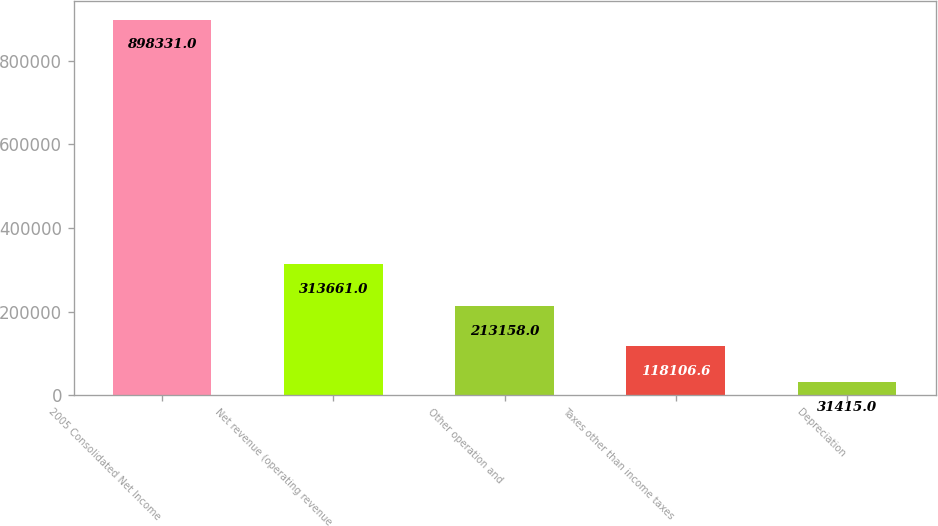Convert chart to OTSL. <chart><loc_0><loc_0><loc_500><loc_500><bar_chart><fcel>2005 Consolidated Net Income<fcel>Net revenue (operating revenue<fcel>Other operation and<fcel>Taxes other than income taxes<fcel>Depreciation<nl><fcel>898331<fcel>313661<fcel>213158<fcel>118107<fcel>31415<nl></chart> 